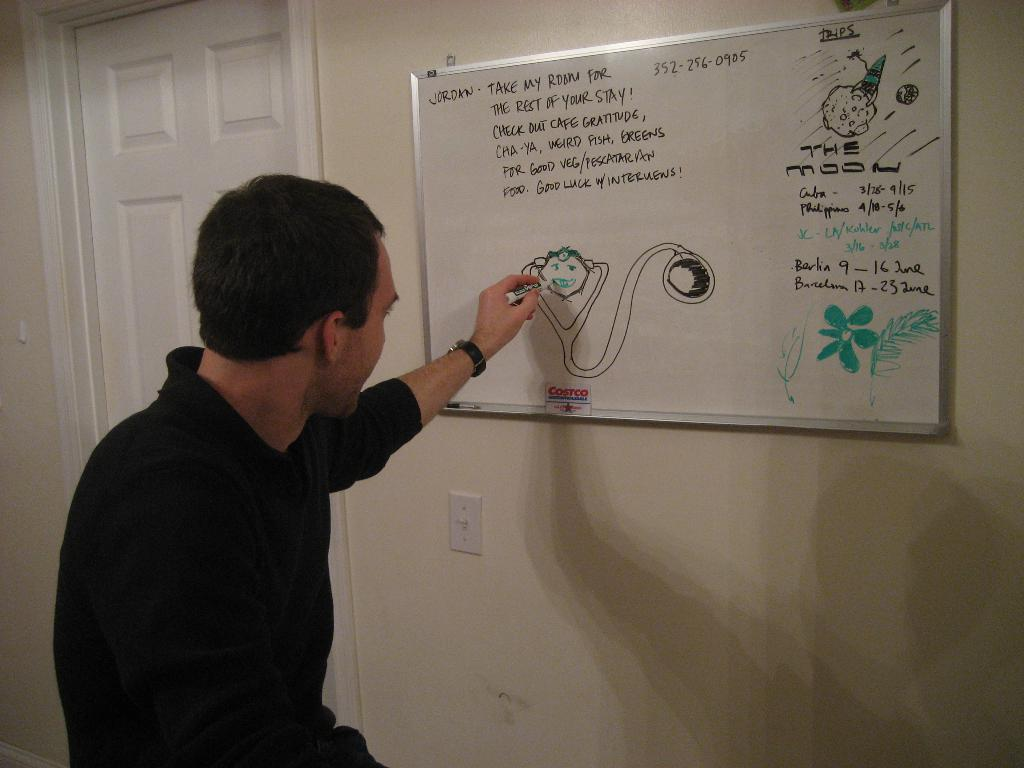<image>
Summarize the visual content of the image. A man is drawing on a whiteboard that has the name Jordan in the upper left corner. 